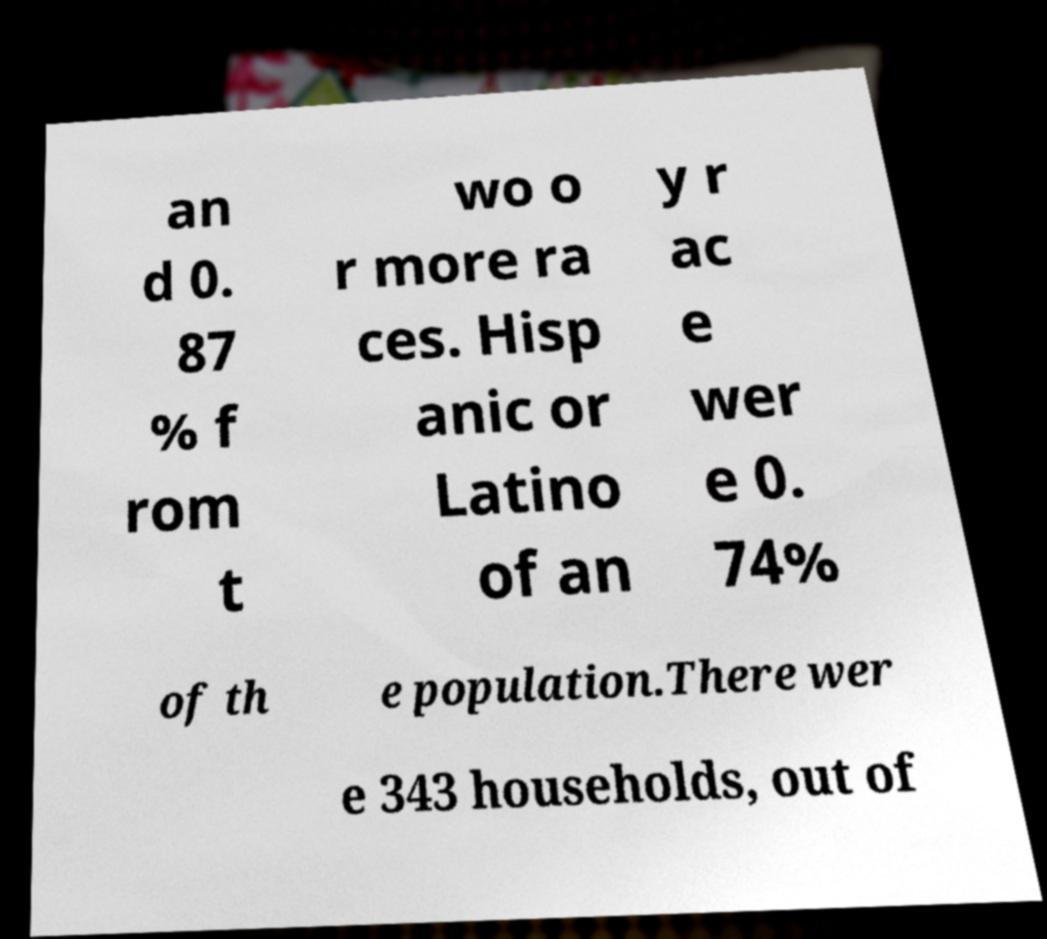For documentation purposes, I need the text within this image transcribed. Could you provide that? an d 0. 87 % f rom t wo o r more ra ces. Hisp anic or Latino of an y r ac e wer e 0. 74% of th e population.There wer e 343 households, out of 